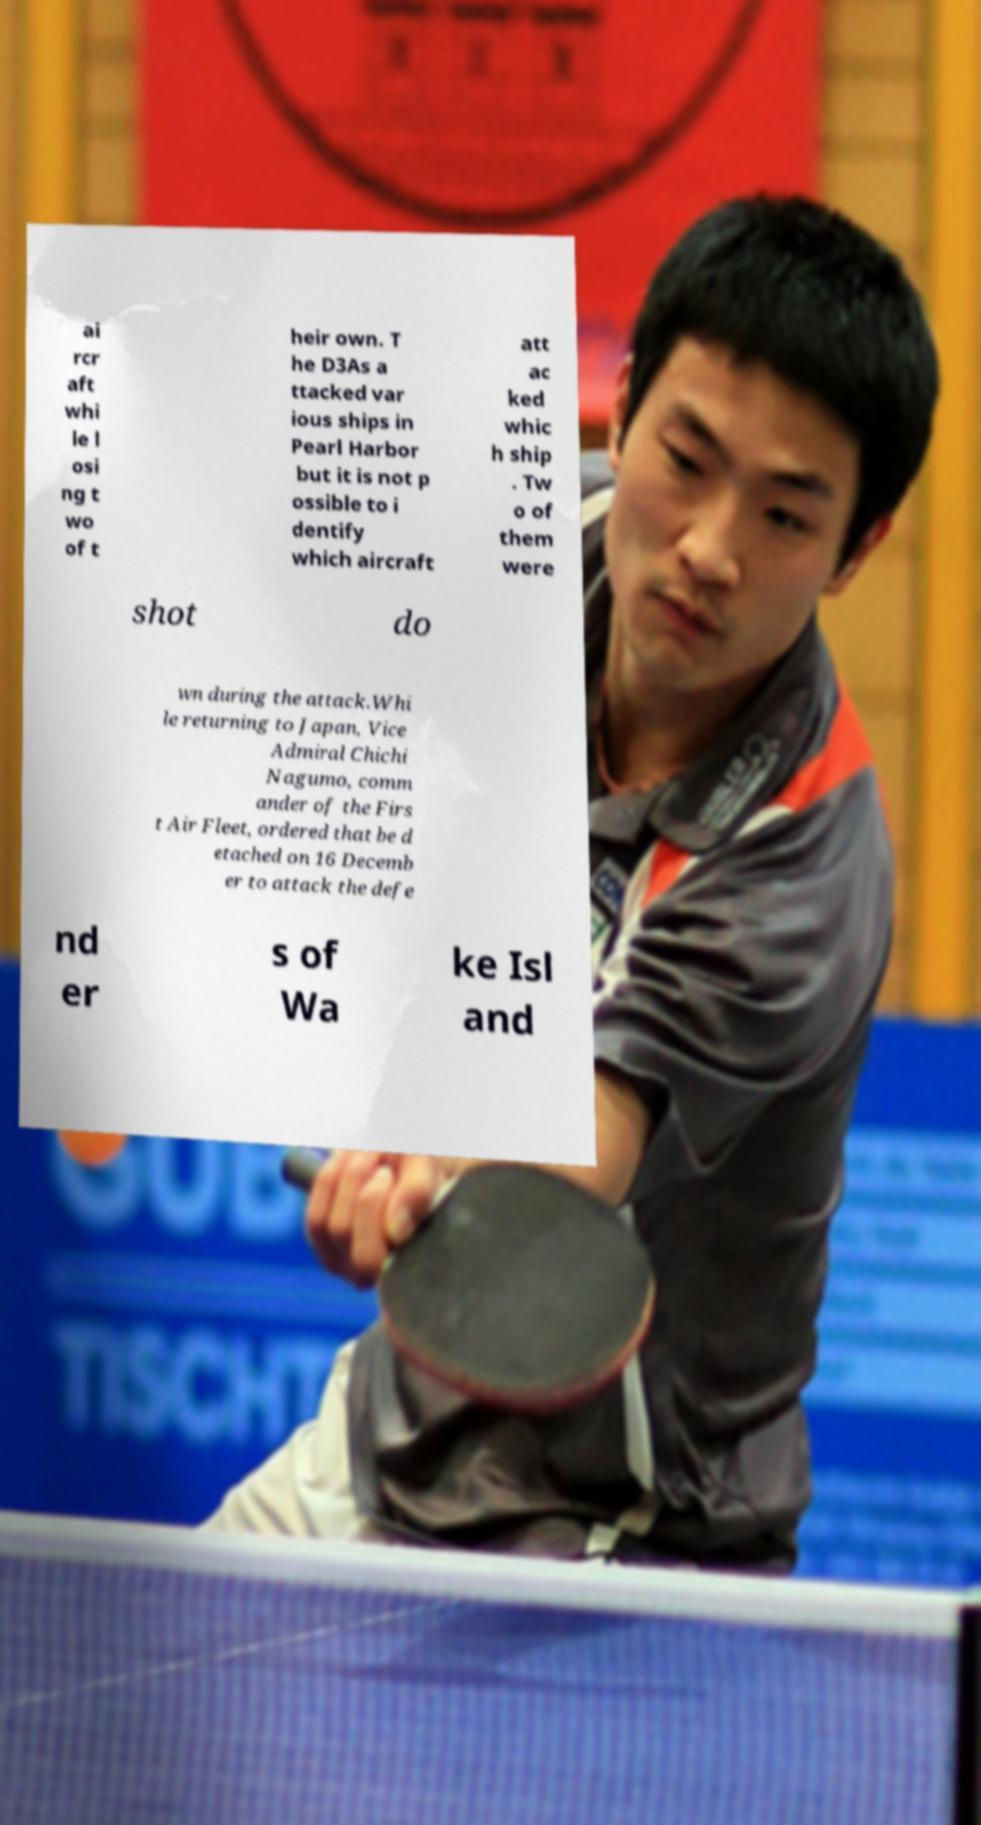Please identify and transcribe the text found in this image. ai rcr aft whi le l osi ng t wo of t heir own. T he D3As a ttacked var ious ships in Pearl Harbor but it is not p ossible to i dentify which aircraft att ac ked whic h ship . Tw o of them were shot do wn during the attack.Whi le returning to Japan, Vice Admiral Chichi Nagumo, comm ander of the Firs t Air Fleet, ordered that be d etached on 16 Decemb er to attack the defe nd er s of Wa ke Isl and 